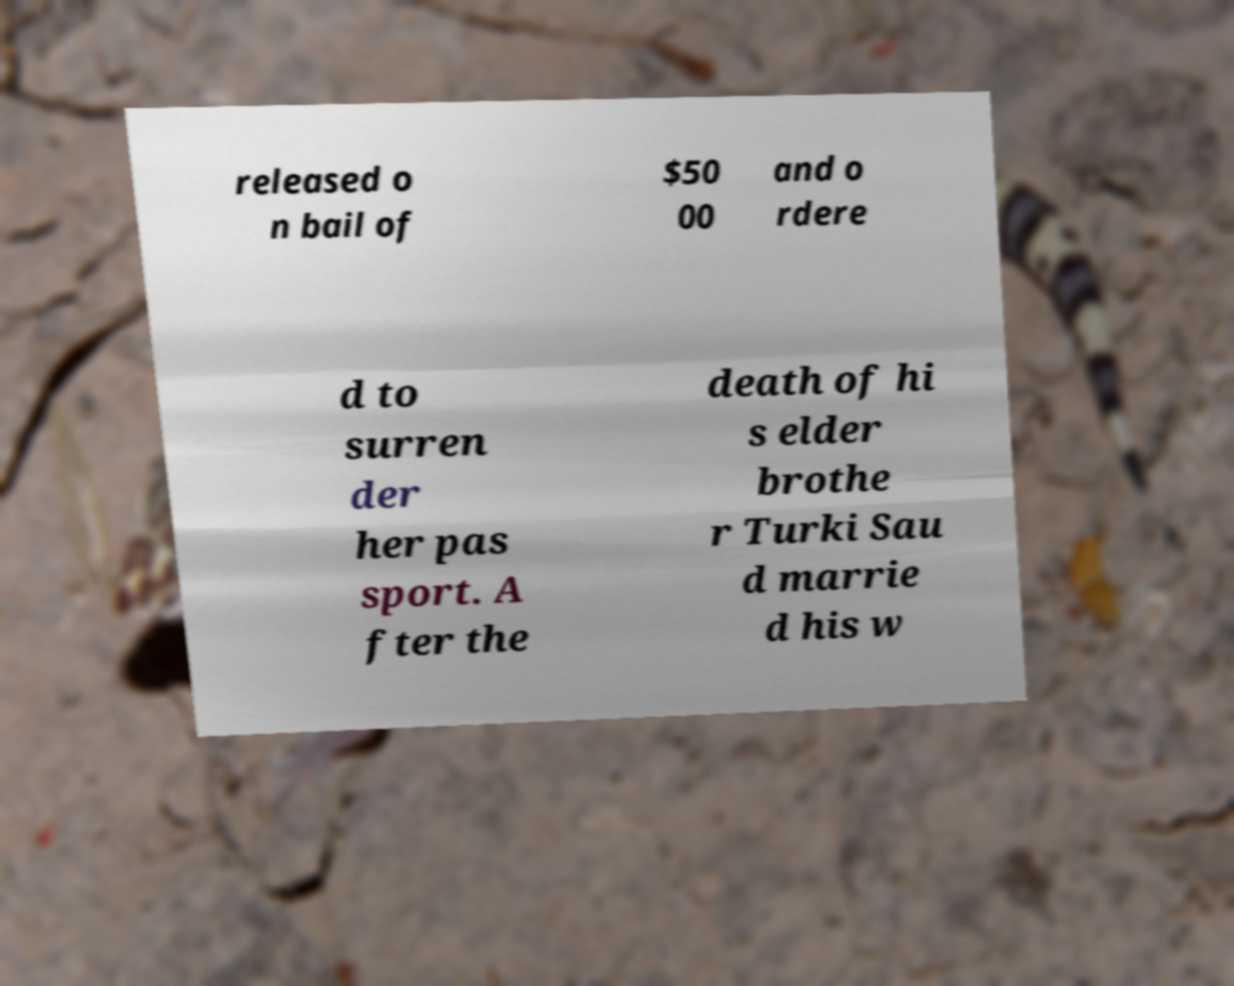Could you assist in decoding the text presented in this image and type it out clearly? released o n bail of $50 00 and o rdere d to surren der her pas sport. A fter the death of hi s elder brothe r Turki Sau d marrie d his w 